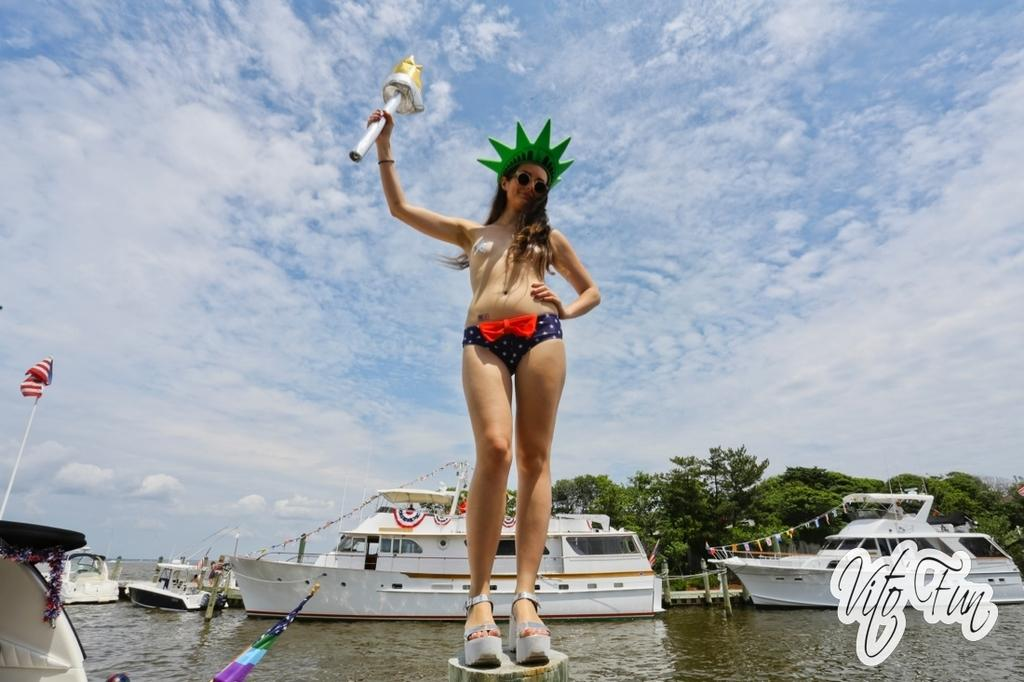What is the woman doing in the image? The woman is standing in the image. What is the woman holding in the image? The woman is holding an object. Can you describe the text in the bottom right corner of the image? There is text in the bottom right corner of the image. What can be seen in the background of the image? Ships, trees, and the sky with clouds are visible in the background. What type of glass is the woman drinking from in the image? There is no glass present in the image, and the woman is not shown drinking. 